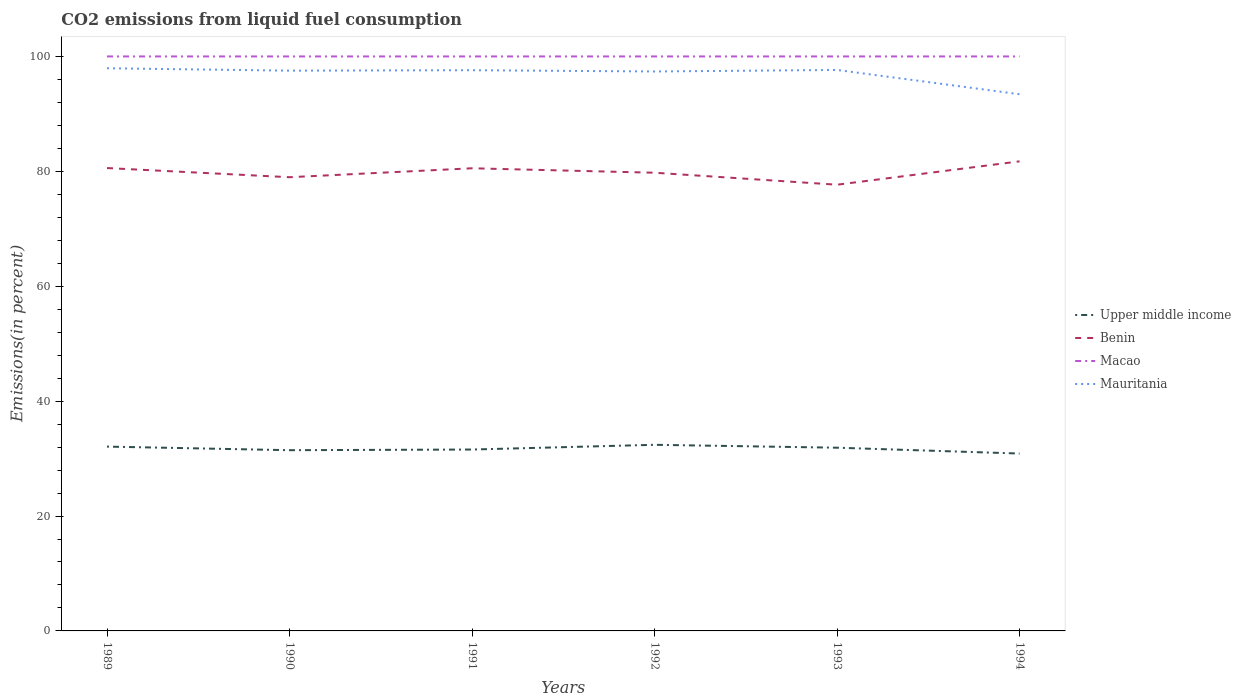How many different coloured lines are there?
Provide a short and direct response. 4. Is the number of lines equal to the number of legend labels?
Your answer should be very brief. Yes. Across all years, what is the maximum total CO2 emitted in Benin?
Give a very brief answer. 77.67. What is the total total CO2 emitted in Benin in the graph?
Offer a very short reply. 1.3. What is the difference between the highest and the second highest total CO2 emitted in Mauritania?
Ensure brevity in your answer.  4.52. How many lines are there?
Provide a short and direct response. 4. How many years are there in the graph?
Your response must be concise. 6. Are the values on the major ticks of Y-axis written in scientific E-notation?
Provide a short and direct response. No. Where does the legend appear in the graph?
Provide a succinct answer. Center right. What is the title of the graph?
Provide a succinct answer. CO2 emissions from liquid fuel consumption. Does "Russian Federation" appear as one of the legend labels in the graph?
Provide a succinct answer. No. What is the label or title of the X-axis?
Provide a short and direct response. Years. What is the label or title of the Y-axis?
Provide a succinct answer. Emissions(in percent). What is the Emissions(in percent) of Upper middle income in 1989?
Provide a short and direct response. 32.08. What is the Emissions(in percent) in Benin in 1989?
Make the answer very short. 80.57. What is the Emissions(in percent) in Mauritania in 1989?
Ensure brevity in your answer.  97.94. What is the Emissions(in percent) of Upper middle income in 1990?
Ensure brevity in your answer.  31.46. What is the Emissions(in percent) in Benin in 1990?
Offer a very short reply. 78.97. What is the Emissions(in percent) in Macao in 1990?
Give a very brief answer. 100. What is the Emissions(in percent) of Mauritania in 1990?
Your answer should be very brief. 97.52. What is the Emissions(in percent) in Upper middle income in 1991?
Offer a very short reply. 31.58. What is the Emissions(in percent) in Benin in 1991?
Provide a short and direct response. 80.53. What is the Emissions(in percent) of Macao in 1991?
Your response must be concise. 100. What is the Emissions(in percent) in Mauritania in 1991?
Your response must be concise. 97.6. What is the Emissions(in percent) in Upper middle income in 1992?
Your response must be concise. 32.4. What is the Emissions(in percent) of Benin in 1992?
Make the answer very short. 79.76. What is the Emissions(in percent) of Mauritania in 1992?
Provide a succinct answer. 97.38. What is the Emissions(in percent) of Upper middle income in 1993?
Offer a terse response. 31.89. What is the Emissions(in percent) in Benin in 1993?
Offer a terse response. 77.67. What is the Emissions(in percent) of Macao in 1993?
Offer a very short reply. 100. What is the Emissions(in percent) of Mauritania in 1993?
Your answer should be very brief. 97.65. What is the Emissions(in percent) of Upper middle income in 1994?
Offer a terse response. 30.88. What is the Emissions(in percent) in Benin in 1994?
Your response must be concise. 81.74. What is the Emissions(in percent) of Macao in 1994?
Keep it short and to the point. 100. What is the Emissions(in percent) in Mauritania in 1994?
Provide a succinct answer. 93.42. Across all years, what is the maximum Emissions(in percent) in Upper middle income?
Offer a terse response. 32.4. Across all years, what is the maximum Emissions(in percent) of Benin?
Your answer should be very brief. 81.74. Across all years, what is the maximum Emissions(in percent) in Mauritania?
Make the answer very short. 97.94. Across all years, what is the minimum Emissions(in percent) in Upper middle income?
Your answer should be very brief. 30.88. Across all years, what is the minimum Emissions(in percent) in Benin?
Offer a terse response. 77.67. Across all years, what is the minimum Emissions(in percent) of Macao?
Offer a very short reply. 100. Across all years, what is the minimum Emissions(in percent) in Mauritania?
Your answer should be compact. 93.42. What is the total Emissions(in percent) of Upper middle income in the graph?
Provide a succinct answer. 190.28. What is the total Emissions(in percent) in Benin in the graph?
Your answer should be very brief. 479.24. What is the total Emissions(in percent) of Macao in the graph?
Your response must be concise. 600. What is the total Emissions(in percent) of Mauritania in the graph?
Offer a terse response. 581.51. What is the difference between the Emissions(in percent) of Upper middle income in 1989 and that in 1990?
Keep it short and to the point. 0.63. What is the difference between the Emissions(in percent) in Benin in 1989 and that in 1990?
Your answer should be compact. 1.6. What is the difference between the Emissions(in percent) of Macao in 1989 and that in 1990?
Make the answer very short. 0. What is the difference between the Emissions(in percent) in Mauritania in 1989 and that in 1990?
Ensure brevity in your answer.  0.42. What is the difference between the Emissions(in percent) in Upper middle income in 1989 and that in 1991?
Your response must be concise. 0.51. What is the difference between the Emissions(in percent) of Benin in 1989 and that in 1991?
Your answer should be compact. 0.04. What is the difference between the Emissions(in percent) in Mauritania in 1989 and that in 1991?
Your response must be concise. 0.34. What is the difference between the Emissions(in percent) in Upper middle income in 1989 and that in 1992?
Give a very brief answer. -0.31. What is the difference between the Emissions(in percent) in Benin in 1989 and that in 1992?
Keep it short and to the point. 0.81. What is the difference between the Emissions(in percent) in Macao in 1989 and that in 1992?
Offer a terse response. 0. What is the difference between the Emissions(in percent) in Mauritania in 1989 and that in 1992?
Keep it short and to the point. 0.56. What is the difference between the Emissions(in percent) of Upper middle income in 1989 and that in 1993?
Ensure brevity in your answer.  0.19. What is the difference between the Emissions(in percent) of Benin in 1989 and that in 1993?
Offer a very short reply. 2.9. What is the difference between the Emissions(in percent) in Mauritania in 1989 and that in 1993?
Offer a terse response. 0.3. What is the difference between the Emissions(in percent) of Upper middle income in 1989 and that in 1994?
Keep it short and to the point. 1.21. What is the difference between the Emissions(in percent) in Benin in 1989 and that in 1994?
Ensure brevity in your answer.  -1.17. What is the difference between the Emissions(in percent) of Macao in 1989 and that in 1994?
Offer a terse response. 0. What is the difference between the Emissions(in percent) of Mauritania in 1989 and that in 1994?
Your answer should be compact. 4.52. What is the difference between the Emissions(in percent) in Upper middle income in 1990 and that in 1991?
Offer a terse response. -0.12. What is the difference between the Emissions(in percent) in Benin in 1990 and that in 1991?
Your answer should be compact. -1.56. What is the difference between the Emissions(in percent) of Macao in 1990 and that in 1991?
Make the answer very short. 0. What is the difference between the Emissions(in percent) in Mauritania in 1990 and that in 1991?
Make the answer very short. -0.08. What is the difference between the Emissions(in percent) in Upper middle income in 1990 and that in 1992?
Offer a terse response. -0.94. What is the difference between the Emissions(in percent) of Benin in 1990 and that in 1992?
Give a very brief answer. -0.78. What is the difference between the Emissions(in percent) in Macao in 1990 and that in 1992?
Ensure brevity in your answer.  0. What is the difference between the Emissions(in percent) of Mauritania in 1990 and that in 1992?
Keep it short and to the point. 0.14. What is the difference between the Emissions(in percent) of Upper middle income in 1990 and that in 1993?
Keep it short and to the point. -0.43. What is the difference between the Emissions(in percent) in Benin in 1990 and that in 1993?
Make the answer very short. 1.3. What is the difference between the Emissions(in percent) in Mauritania in 1990 and that in 1993?
Offer a very short reply. -0.12. What is the difference between the Emissions(in percent) in Upper middle income in 1990 and that in 1994?
Make the answer very short. 0.58. What is the difference between the Emissions(in percent) of Benin in 1990 and that in 1994?
Provide a short and direct response. -2.76. What is the difference between the Emissions(in percent) of Macao in 1990 and that in 1994?
Ensure brevity in your answer.  0. What is the difference between the Emissions(in percent) of Mauritania in 1990 and that in 1994?
Keep it short and to the point. 4.1. What is the difference between the Emissions(in percent) in Upper middle income in 1991 and that in 1992?
Offer a terse response. -0.82. What is the difference between the Emissions(in percent) in Benin in 1991 and that in 1992?
Offer a very short reply. 0.77. What is the difference between the Emissions(in percent) in Macao in 1991 and that in 1992?
Ensure brevity in your answer.  0. What is the difference between the Emissions(in percent) of Mauritania in 1991 and that in 1992?
Offer a very short reply. 0.22. What is the difference between the Emissions(in percent) of Upper middle income in 1991 and that in 1993?
Your answer should be very brief. -0.32. What is the difference between the Emissions(in percent) of Benin in 1991 and that in 1993?
Provide a short and direct response. 2.86. What is the difference between the Emissions(in percent) in Macao in 1991 and that in 1993?
Offer a terse response. 0. What is the difference between the Emissions(in percent) in Mauritania in 1991 and that in 1993?
Offer a very short reply. -0.05. What is the difference between the Emissions(in percent) of Upper middle income in 1991 and that in 1994?
Give a very brief answer. 0.7. What is the difference between the Emissions(in percent) in Benin in 1991 and that in 1994?
Give a very brief answer. -1.21. What is the difference between the Emissions(in percent) of Macao in 1991 and that in 1994?
Offer a terse response. 0. What is the difference between the Emissions(in percent) of Mauritania in 1991 and that in 1994?
Your answer should be compact. 4.18. What is the difference between the Emissions(in percent) in Upper middle income in 1992 and that in 1993?
Your answer should be very brief. 0.5. What is the difference between the Emissions(in percent) in Benin in 1992 and that in 1993?
Ensure brevity in your answer.  2.09. What is the difference between the Emissions(in percent) in Macao in 1992 and that in 1993?
Offer a very short reply. 0. What is the difference between the Emissions(in percent) of Mauritania in 1992 and that in 1993?
Provide a succinct answer. -0.26. What is the difference between the Emissions(in percent) of Upper middle income in 1992 and that in 1994?
Give a very brief answer. 1.52. What is the difference between the Emissions(in percent) in Benin in 1992 and that in 1994?
Your answer should be compact. -1.98. What is the difference between the Emissions(in percent) in Macao in 1992 and that in 1994?
Your answer should be very brief. 0. What is the difference between the Emissions(in percent) of Mauritania in 1992 and that in 1994?
Ensure brevity in your answer.  3.96. What is the difference between the Emissions(in percent) of Upper middle income in 1993 and that in 1994?
Offer a terse response. 1.02. What is the difference between the Emissions(in percent) of Benin in 1993 and that in 1994?
Ensure brevity in your answer.  -4.07. What is the difference between the Emissions(in percent) of Macao in 1993 and that in 1994?
Make the answer very short. 0. What is the difference between the Emissions(in percent) of Mauritania in 1993 and that in 1994?
Your answer should be compact. 4.23. What is the difference between the Emissions(in percent) in Upper middle income in 1989 and the Emissions(in percent) in Benin in 1990?
Offer a very short reply. -46.89. What is the difference between the Emissions(in percent) in Upper middle income in 1989 and the Emissions(in percent) in Macao in 1990?
Offer a very short reply. -67.92. What is the difference between the Emissions(in percent) in Upper middle income in 1989 and the Emissions(in percent) in Mauritania in 1990?
Give a very brief answer. -65.44. What is the difference between the Emissions(in percent) in Benin in 1989 and the Emissions(in percent) in Macao in 1990?
Provide a succinct answer. -19.43. What is the difference between the Emissions(in percent) in Benin in 1989 and the Emissions(in percent) in Mauritania in 1990?
Your answer should be very brief. -16.95. What is the difference between the Emissions(in percent) in Macao in 1989 and the Emissions(in percent) in Mauritania in 1990?
Offer a terse response. 2.48. What is the difference between the Emissions(in percent) of Upper middle income in 1989 and the Emissions(in percent) of Benin in 1991?
Ensure brevity in your answer.  -48.45. What is the difference between the Emissions(in percent) in Upper middle income in 1989 and the Emissions(in percent) in Macao in 1991?
Give a very brief answer. -67.92. What is the difference between the Emissions(in percent) in Upper middle income in 1989 and the Emissions(in percent) in Mauritania in 1991?
Your response must be concise. -65.52. What is the difference between the Emissions(in percent) of Benin in 1989 and the Emissions(in percent) of Macao in 1991?
Ensure brevity in your answer.  -19.43. What is the difference between the Emissions(in percent) in Benin in 1989 and the Emissions(in percent) in Mauritania in 1991?
Your answer should be compact. -17.03. What is the difference between the Emissions(in percent) in Macao in 1989 and the Emissions(in percent) in Mauritania in 1991?
Your response must be concise. 2.4. What is the difference between the Emissions(in percent) in Upper middle income in 1989 and the Emissions(in percent) in Benin in 1992?
Your response must be concise. -47.67. What is the difference between the Emissions(in percent) of Upper middle income in 1989 and the Emissions(in percent) of Macao in 1992?
Your answer should be very brief. -67.92. What is the difference between the Emissions(in percent) in Upper middle income in 1989 and the Emissions(in percent) in Mauritania in 1992?
Offer a terse response. -65.3. What is the difference between the Emissions(in percent) in Benin in 1989 and the Emissions(in percent) in Macao in 1992?
Your answer should be very brief. -19.43. What is the difference between the Emissions(in percent) of Benin in 1989 and the Emissions(in percent) of Mauritania in 1992?
Your answer should be compact. -16.81. What is the difference between the Emissions(in percent) of Macao in 1989 and the Emissions(in percent) of Mauritania in 1992?
Offer a very short reply. 2.62. What is the difference between the Emissions(in percent) in Upper middle income in 1989 and the Emissions(in percent) in Benin in 1993?
Offer a very short reply. -45.59. What is the difference between the Emissions(in percent) of Upper middle income in 1989 and the Emissions(in percent) of Macao in 1993?
Your response must be concise. -67.92. What is the difference between the Emissions(in percent) of Upper middle income in 1989 and the Emissions(in percent) of Mauritania in 1993?
Provide a succinct answer. -65.56. What is the difference between the Emissions(in percent) in Benin in 1989 and the Emissions(in percent) in Macao in 1993?
Make the answer very short. -19.43. What is the difference between the Emissions(in percent) of Benin in 1989 and the Emissions(in percent) of Mauritania in 1993?
Your response must be concise. -17.07. What is the difference between the Emissions(in percent) in Macao in 1989 and the Emissions(in percent) in Mauritania in 1993?
Make the answer very short. 2.35. What is the difference between the Emissions(in percent) of Upper middle income in 1989 and the Emissions(in percent) of Benin in 1994?
Ensure brevity in your answer.  -49.66. What is the difference between the Emissions(in percent) in Upper middle income in 1989 and the Emissions(in percent) in Macao in 1994?
Make the answer very short. -67.92. What is the difference between the Emissions(in percent) of Upper middle income in 1989 and the Emissions(in percent) of Mauritania in 1994?
Offer a very short reply. -61.34. What is the difference between the Emissions(in percent) of Benin in 1989 and the Emissions(in percent) of Macao in 1994?
Your answer should be very brief. -19.43. What is the difference between the Emissions(in percent) in Benin in 1989 and the Emissions(in percent) in Mauritania in 1994?
Ensure brevity in your answer.  -12.85. What is the difference between the Emissions(in percent) in Macao in 1989 and the Emissions(in percent) in Mauritania in 1994?
Offer a very short reply. 6.58. What is the difference between the Emissions(in percent) of Upper middle income in 1990 and the Emissions(in percent) of Benin in 1991?
Keep it short and to the point. -49.07. What is the difference between the Emissions(in percent) in Upper middle income in 1990 and the Emissions(in percent) in Macao in 1991?
Provide a short and direct response. -68.54. What is the difference between the Emissions(in percent) of Upper middle income in 1990 and the Emissions(in percent) of Mauritania in 1991?
Your response must be concise. -66.14. What is the difference between the Emissions(in percent) of Benin in 1990 and the Emissions(in percent) of Macao in 1991?
Make the answer very short. -21.03. What is the difference between the Emissions(in percent) in Benin in 1990 and the Emissions(in percent) in Mauritania in 1991?
Keep it short and to the point. -18.63. What is the difference between the Emissions(in percent) of Macao in 1990 and the Emissions(in percent) of Mauritania in 1991?
Your answer should be very brief. 2.4. What is the difference between the Emissions(in percent) of Upper middle income in 1990 and the Emissions(in percent) of Benin in 1992?
Keep it short and to the point. -48.3. What is the difference between the Emissions(in percent) of Upper middle income in 1990 and the Emissions(in percent) of Macao in 1992?
Your answer should be very brief. -68.54. What is the difference between the Emissions(in percent) in Upper middle income in 1990 and the Emissions(in percent) in Mauritania in 1992?
Your response must be concise. -65.92. What is the difference between the Emissions(in percent) of Benin in 1990 and the Emissions(in percent) of Macao in 1992?
Provide a short and direct response. -21.03. What is the difference between the Emissions(in percent) in Benin in 1990 and the Emissions(in percent) in Mauritania in 1992?
Offer a very short reply. -18.41. What is the difference between the Emissions(in percent) of Macao in 1990 and the Emissions(in percent) of Mauritania in 1992?
Offer a terse response. 2.62. What is the difference between the Emissions(in percent) of Upper middle income in 1990 and the Emissions(in percent) of Benin in 1993?
Provide a short and direct response. -46.21. What is the difference between the Emissions(in percent) of Upper middle income in 1990 and the Emissions(in percent) of Macao in 1993?
Keep it short and to the point. -68.54. What is the difference between the Emissions(in percent) of Upper middle income in 1990 and the Emissions(in percent) of Mauritania in 1993?
Give a very brief answer. -66.19. What is the difference between the Emissions(in percent) of Benin in 1990 and the Emissions(in percent) of Macao in 1993?
Offer a terse response. -21.03. What is the difference between the Emissions(in percent) in Benin in 1990 and the Emissions(in percent) in Mauritania in 1993?
Your response must be concise. -18.67. What is the difference between the Emissions(in percent) of Macao in 1990 and the Emissions(in percent) of Mauritania in 1993?
Your answer should be compact. 2.35. What is the difference between the Emissions(in percent) in Upper middle income in 1990 and the Emissions(in percent) in Benin in 1994?
Your answer should be compact. -50.28. What is the difference between the Emissions(in percent) in Upper middle income in 1990 and the Emissions(in percent) in Macao in 1994?
Your answer should be very brief. -68.54. What is the difference between the Emissions(in percent) of Upper middle income in 1990 and the Emissions(in percent) of Mauritania in 1994?
Your response must be concise. -61.96. What is the difference between the Emissions(in percent) of Benin in 1990 and the Emissions(in percent) of Macao in 1994?
Your response must be concise. -21.03. What is the difference between the Emissions(in percent) in Benin in 1990 and the Emissions(in percent) in Mauritania in 1994?
Provide a short and direct response. -14.45. What is the difference between the Emissions(in percent) of Macao in 1990 and the Emissions(in percent) of Mauritania in 1994?
Offer a very short reply. 6.58. What is the difference between the Emissions(in percent) of Upper middle income in 1991 and the Emissions(in percent) of Benin in 1992?
Ensure brevity in your answer.  -48.18. What is the difference between the Emissions(in percent) in Upper middle income in 1991 and the Emissions(in percent) in Macao in 1992?
Keep it short and to the point. -68.42. What is the difference between the Emissions(in percent) of Upper middle income in 1991 and the Emissions(in percent) of Mauritania in 1992?
Your answer should be very brief. -65.81. What is the difference between the Emissions(in percent) in Benin in 1991 and the Emissions(in percent) in Macao in 1992?
Your response must be concise. -19.47. What is the difference between the Emissions(in percent) of Benin in 1991 and the Emissions(in percent) of Mauritania in 1992?
Your response must be concise. -16.85. What is the difference between the Emissions(in percent) of Macao in 1991 and the Emissions(in percent) of Mauritania in 1992?
Your answer should be compact. 2.62. What is the difference between the Emissions(in percent) in Upper middle income in 1991 and the Emissions(in percent) in Benin in 1993?
Provide a succinct answer. -46.09. What is the difference between the Emissions(in percent) in Upper middle income in 1991 and the Emissions(in percent) in Macao in 1993?
Offer a very short reply. -68.42. What is the difference between the Emissions(in percent) of Upper middle income in 1991 and the Emissions(in percent) of Mauritania in 1993?
Your response must be concise. -66.07. What is the difference between the Emissions(in percent) of Benin in 1991 and the Emissions(in percent) of Macao in 1993?
Your answer should be compact. -19.47. What is the difference between the Emissions(in percent) in Benin in 1991 and the Emissions(in percent) in Mauritania in 1993?
Your answer should be compact. -17.11. What is the difference between the Emissions(in percent) of Macao in 1991 and the Emissions(in percent) of Mauritania in 1993?
Provide a succinct answer. 2.35. What is the difference between the Emissions(in percent) in Upper middle income in 1991 and the Emissions(in percent) in Benin in 1994?
Your response must be concise. -50.16. What is the difference between the Emissions(in percent) of Upper middle income in 1991 and the Emissions(in percent) of Macao in 1994?
Your response must be concise. -68.42. What is the difference between the Emissions(in percent) of Upper middle income in 1991 and the Emissions(in percent) of Mauritania in 1994?
Your response must be concise. -61.84. What is the difference between the Emissions(in percent) of Benin in 1991 and the Emissions(in percent) of Macao in 1994?
Ensure brevity in your answer.  -19.47. What is the difference between the Emissions(in percent) of Benin in 1991 and the Emissions(in percent) of Mauritania in 1994?
Your answer should be very brief. -12.89. What is the difference between the Emissions(in percent) of Macao in 1991 and the Emissions(in percent) of Mauritania in 1994?
Ensure brevity in your answer.  6.58. What is the difference between the Emissions(in percent) of Upper middle income in 1992 and the Emissions(in percent) of Benin in 1993?
Ensure brevity in your answer.  -45.27. What is the difference between the Emissions(in percent) in Upper middle income in 1992 and the Emissions(in percent) in Macao in 1993?
Provide a short and direct response. -67.6. What is the difference between the Emissions(in percent) of Upper middle income in 1992 and the Emissions(in percent) of Mauritania in 1993?
Provide a short and direct response. -65.25. What is the difference between the Emissions(in percent) of Benin in 1992 and the Emissions(in percent) of Macao in 1993?
Offer a terse response. -20.24. What is the difference between the Emissions(in percent) of Benin in 1992 and the Emissions(in percent) of Mauritania in 1993?
Your answer should be very brief. -17.89. What is the difference between the Emissions(in percent) in Macao in 1992 and the Emissions(in percent) in Mauritania in 1993?
Provide a short and direct response. 2.35. What is the difference between the Emissions(in percent) in Upper middle income in 1992 and the Emissions(in percent) in Benin in 1994?
Keep it short and to the point. -49.34. What is the difference between the Emissions(in percent) in Upper middle income in 1992 and the Emissions(in percent) in Macao in 1994?
Give a very brief answer. -67.6. What is the difference between the Emissions(in percent) in Upper middle income in 1992 and the Emissions(in percent) in Mauritania in 1994?
Give a very brief answer. -61.02. What is the difference between the Emissions(in percent) in Benin in 1992 and the Emissions(in percent) in Macao in 1994?
Your answer should be very brief. -20.24. What is the difference between the Emissions(in percent) of Benin in 1992 and the Emissions(in percent) of Mauritania in 1994?
Provide a short and direct response. -13.66. What is the difference between the Emissions(in percent) of Macao in 1992 and the Emissions(in percent) of Mauritania in 1994?
Make the answer very short. 6.58. What is the difference between the Emissions(in percent) in Upper middle income in 1993 and the Emissions(in percent) in Benin in 1994?
Offer a very short reply. -49.85. What is the difference between the Emissions(in percent) in Upper middle income in 1993 and the Emissions(in percent) in Macao in 1994?
Your answer should be very brief. -68.11. What is the difference between the Emissions(in percent) of Upper middle income in 1993 and the Emissions(in percent) of Mauritania in 1994?
Provide a succinct answer. -61.53. What is the difference between the Emissions(in percent) in Benin in 1993 and the Emissions(in percent) in Macao in 1994?
Provide a succinct answer. -22.33. What is the difference between the Emissions(in percent) in Benin in 1993 and the Emissions(in percent) in Mauritania in 1994?
Provide a succinct answer. -15.75. What is the difference between the Emissions(in percent) in Macao in 1993 and the Emissions(in percent) in Mauritania in 1994?
Your answer should be compact. 6.58. What is the average Emissions(in percent) in Upper middle income per year?
Ensure brevity in your answer.  31.71. What is the average Emissions(in percent) in Benin per year?
Your response must be concise. 79.87. What is the average Emissions(in percent) in Macao per year?
Make the answer very short. 100. What is the average Emissions(in percent) of Mauritania per year?
Make the answer very short. 96.92. In the year 1989, what is the difference between the Emissions(in percent) in Upper middle income and Emissions(in percent) in Benin?
Offer a very short reply. -48.49. In the year 1989, what is the difference between the Emissions(in percent) of Upper middle income and Emissions(in percent) of Macao?
Offer a very short reply. -67.92. In the year 1989, what is the difference between the Emissions(in percent) in Upper middle income and Emissions(in percent) in Mauritania?
Keep it short and to the point. -65.86. In the year 1989, what is the difference between the Emissions(in percent) in Benin and Emissions(in percent) in Macao?
Your response must be concise. -19.43. In the year 1989, what is the difference between the Emissions(in percent) of Benin and Emissions(in percent) of Mauritania?
Give a very brief answer. -17.37. In the year 1989, what is the difference between the Emissions(in percent) in Macao and Emissions(in percent) in Mauritania?
Offer a very short reply. 2.06. In the year 1990, what is the difference between the Emissions(in percent) of Upper middle income and Emissions(in percent) of Benin?
Keep it short and to the point. -47.52. In the year 1990, what is the difference between the Emissions(in percent) of Upper middle income and Emissions(in percent) of Macao?
Ensure brevity in your answer.  -68.54. In the year 1990, what is the difference between the Emissions(in percent) of Upper middle income and Emissions(in percent) of Mauritania?
Make the answer very short. -66.07. In the year 1990, what is the difference between the Emissions(in percent) in Benin and Emissions(in percent) in Macao?
Provide a short and direct response. -21.03. In the year 1990, what is the difference between the Emissions(in percent) in Benin and Emissions(in percent) in Mauritania?
Make the answer very short. -18.55. In the year 1990, what is the difference between the Emissions(in percent) of Macao and Emissions(in percent) of Mauritania?
Your response must be concise. 2.48. In the year 1991, what is the difference between the Emissions(in percent) in Upper middle income and Emissions(in percent) in Benin?
Give a very brief answer. -48.96. In the year 1991, what is the difference between the Emissions(in percent) of Upper middle income and Emissions(in percent) of Macao?
Your response must be concise. -68.42. In the year 1991, what is the difference between the Emissions(in percent) of Upper middle income and Emissions(in percent) of Mauritania?
Provide a short and direct response. -66.02. In the year 1991, what is the difference between the Emissions(in percent) in Benin and Emissions(in percent) in Macao?
Your response must be concise. -19.47. In the year 1991, what is the difference between the Emissions(in percent) of Benin and Emissions(in percent) of Mauritania?
Your answer should be compact. -17.07. In the year 1992, what is the difference between the Emissions(in percent) in Upper middle income and Emissions(in percent) in Benin?
Provide a succinct answer. -47.36. In the year 1992, what is the difference between the Emissions(in percent) of Upper middle income and Emissions(in percent) of Macao?
Your answer should be compact. -67.6. In the year 1992, what is the difference between the Emissions(in percent) in Upper middle income and Emissions(in percent) in Mauritania?
Your answer should be compact. -64.99. In the year 1992, what is the difference between the Emissions(in percent) in Benin and Emissions(in percent) in Macao?
Your answer should be compact. -20.24. In the year 1992, what is the difference between the Emissions(in percent) in Benin and Emissions(in percent) in Mauritania?
Your answer should be very brief. -17.62. In the year 1992, what is the difference between the Emissions(in percent) of Macao and Emissions(in percent) of Mauritania?
Your answer should be very brief. 2.62. In the year 1993, what is the difference between the Emissions(in percent) in Upper middle income and Emissions(in percent) in Benin?
Ensure brevity in your answer.  -45.78. In the year 1993, what is the difference between the Emissions(in percent) of Upper middle income and Emissions(in percent) of Macao?
Offer a terse response. -68.11. In the year 1993, what is the difference between the Emissions(in percent) in Upper middle income and Emissions(in percent) in Mauritania?
Keep it short and to the point. -65.75. In the year 1993, what is the difference between the Emissions(in percent) of Benin and Emissions(in percent) of Macao?
Your answer should be compact. -22.33. In the year 1993, what is the difference between the Emissions(in percent) of Benin and Emissions(in percent) of Mauritania?
Keep it short and to the point. -19.98. In the year 1993, what is the difference between the Emissions(in percent) of Macao and Emissions(in percent) of Mauritania?
Your answer should be compact. 2.35. In the year 1994, what is the difference between the Emissions(in percent) of Upper middle income and Emissions(in percent) of Benin?
Provide a succinct answer. -50.86. In the year 1994, what is the difference between the Emissions(in percent) of Upper middle income and Emissions(in percent) of Macao?
Provide a short and direct response. -69.12. In the year 1994, what is the difference between the Emissions(in percent) of Upper middle income and Emissions(in percent) of Mauritania?
Your answer should be compact. -62.54. In the year 1994, what is the difference between the Emissions(in percent) of Benin and Emissions(in percent) of Macao?
Ensure brevity in your answer.  -18.26. In the year 1994, what is the difference between the Emissions(in percent) in Benin and Emissions(in percent) in Mauritania?
Your answer should be compact. -11.68. In the year 1994, what is the difference between the Emissions(in percent) in Macao and Emissions(in percent) in Mauritania?
Ensure brevity in your answer.  6.58. What is the ratio of the Emissions(in percent) of Upper middle income in 1989 to that in 1990?
Ensure brevity in your answer.  1.02. What is the ratio of the Emissions(in percent) in Benin in 1989 to that in 1990?
Ensure brevity in your answer.  1.02. What is the ratio of the Emissions(in percent) in Macao in 1989 to that in 1990?
Ensure brevity in your answer.  1. What is the ratio of the Emissions(in percent) of Upper middle income in 1989 to that in 1991?
Provide a succinct answer. 1.02. What is the ratio of the Emissions(in percent) in Benin in 1989 to that in 1991?
Your response must be concise. 1. What is the ratio of the Emissions(in percent) in Macao in 1989 to that in 1991?
Keep it short and to the point. 1. What is the ratio of the Emissions(in percent) in Mauritania in 1989 to that in 1991?
Offer a very short reply. 1. What is the ratio of the Emissions(in percent) of Benin in 1989 to that in 1992?
Your answer should be compact. 1.01. What is the ratio of the Emissions(in percent) in Macao in 1989 to that in 1992?
Your response must be concise. 1. What is the ratio of the Emissions(in percent) of Mauritania in 1989 to that in 1992?
Your response must be concise. 1.01. What is the ratio of the Emissions(in percent) of Upper middle income in 1989 to that in 1993?
Provide a short and direct response. 1.01. What is the ratio of the Emissions(in percent) of Benin in 1989 to that in 1993?
Give a very brief answer. 1.04. What is the ratio of the Emissions(in percent) of Mauritania in 1989 to that in 1993?
Provide a succinct answer. 1. What is the ratio of the Emissions(in percent) of Upper middle income in 1989 to that in 1994?
Your answer should be compact. 1.04. What is the ratio of the Emissions(in percent) in Benin in 1989 to that in 1994?
Offer a very short reply. 0.99. What is the ratio of the Emissions(in percent) in Mauritania in 1989 to that in 1994?
Offer a very short reply. 1.05. What is the ratio of the Emissions(in percent) of Benin in 1990 to that in 1991?
Give a very brief answer. 0.98. What is the ratio of the Emissions(in percent) in Mauritania in 1990 to that in 1991?
Provide a succinct answer. 1. What is the ratio of the Emissions(in percent) in Upper middle income in 1990 to that in 1992?
Your answer should be very brief. 0.97. What is the ratio of the Emissions(in percent) of Benin in 1990 to that in 1992?
Provide a succinct answer. 0.99. What is the ratio of the Emissions(in percent) in Macao in 1990 to that in 1992?
Make the answer very short. 1. What is the ratio of the Emissions(in percent) in Mauritania in 1990 to that in 1992?
Ensure brevity in your answer.  1. What is the ratio of the Emissions(in percent) in Upper middle income in 1990 to that in 1993?
Ensure brevity in your answer.  0.99. What is the ratio of the Emissions(in percent) of Benin in 1990 to that in 1993?
Keep it short and to the point. 1.02. What is the ratio of the Emissions(in percent) in Upper middle income in 1990 to that in 1994?
Provide a short and direct response. 1.02. What is the ratio of the Emissions(in percent) in Benin in 1990 to that in 1994?
Your answer should be compact. 0.97. What is the ratio of the Emissions(in percent) of Mauritania in 1990 to that in 1994?
Ensure brevity in your answer.  1.04. What is the ratio of the Emissions(in percent) of Upper middle income in 1991 to that in 1992?
Keep it short and to the point. 0.97. What is the ratio of the Emissions(in percent) in Benin in 1991 to that in 1992?
Offer a very short reply. 1.01. What is the ratio of the Emissions(in percent) of Macao in 1991 to that in 1992?
Keep it short and to the point. 1. What is the ratio of the Emissions(in percent) of Benin in 1991 to that in 1993?
Keep it short and to the point. 1.04. What is the ratio of the Emissions(in percent) in Macao in 1991 to that in 1993?
Your response must be concise. 1. What is the ratio of the Emissions(in percent) in Mauritania in 1991 to that in 1993?
Your response must be concise. 1. What is the ratio of the Emissions(in percent) in Upper middle income in 1991 to that in 1994?
Make the answer very short. 1.02. What is the ratio of the Emissions(in percent) of Benin in 1991 to that in 1994?
Keep it short and to the point. 0.99. What is the ratio of the Emissions(in percent) of Mauritania in 1991 to that in 1994?
Your answer should be very brief. 1.04. What is the ratio of the Emissions(in percent) in Upper middle income in 1992 to that in 1993?
Your answer should be very brief. 1.02. What is the ratio of the Emissions(in percent) in Benin in 1992 to that in 1993?
Your response must be concise. 1.03. What is the ratio of the Emissions(in percent) of Mauritania in 1992 to that in 1993?
Provide a succinct answer. 1. What is the ratio of the Emissions(in percent) of Upper middle income in 1992 to that in 1994?
Your answer should be compact. 1.05. What is the ratio of the Emissions(in percent) in Benin in 1992 to that in 1994?
Provide a short and direct response. 0.98. What is the ratio of the Emissions(in percent) of Mauritania in 1992 to that in 1994?
Your answer should be very brief. 1.04. What is the ratio of the Emissions(in percent) in Upper middle income in 1993 to that in 1994?
Provide a short and direct response. 1.03. What is the ratio of the Emissions(in percent) of Benin in 1993 to that in 1994?
Make the answer very short. 0.95. What is the ratio of the Emissions(in percent) of Macao in 1993 to that in 1994?
Offer a very short reply. 1. What is the ratio of the Emissions(in percent) in Mauritania in 1993 to that in 1994?
Provide a short and direct response. 1.05. What is the difference between the highest and the second highest Emissions(in percent) in Upper middle income?
Your answer should be very brief. 0.31. What is the difference between the highest and the second highest Emissions(in percent) of Benin?
Your response must be concise. 1.17. What is the difference between the highest and the second highest Emissions(in percent) of Mauritania?
Offer a very short reply. 0.3. What is the difference between the highest and the lowest Emissions(in percent) of Upper middle income?
Your answer should be very brief. 1.52. What is the difference between the highest and the lowest Emissions(in percent) in Benin?
Offer a terse response. 4.07. What is the difference between the highest and the lowest Emissions(in percent) in Macao?
Provide a succinct answer. 0. What is the difference between the highest and the lowest Emissions(in percent) of Mauritania?
Your answer should be compact. 4.52. 